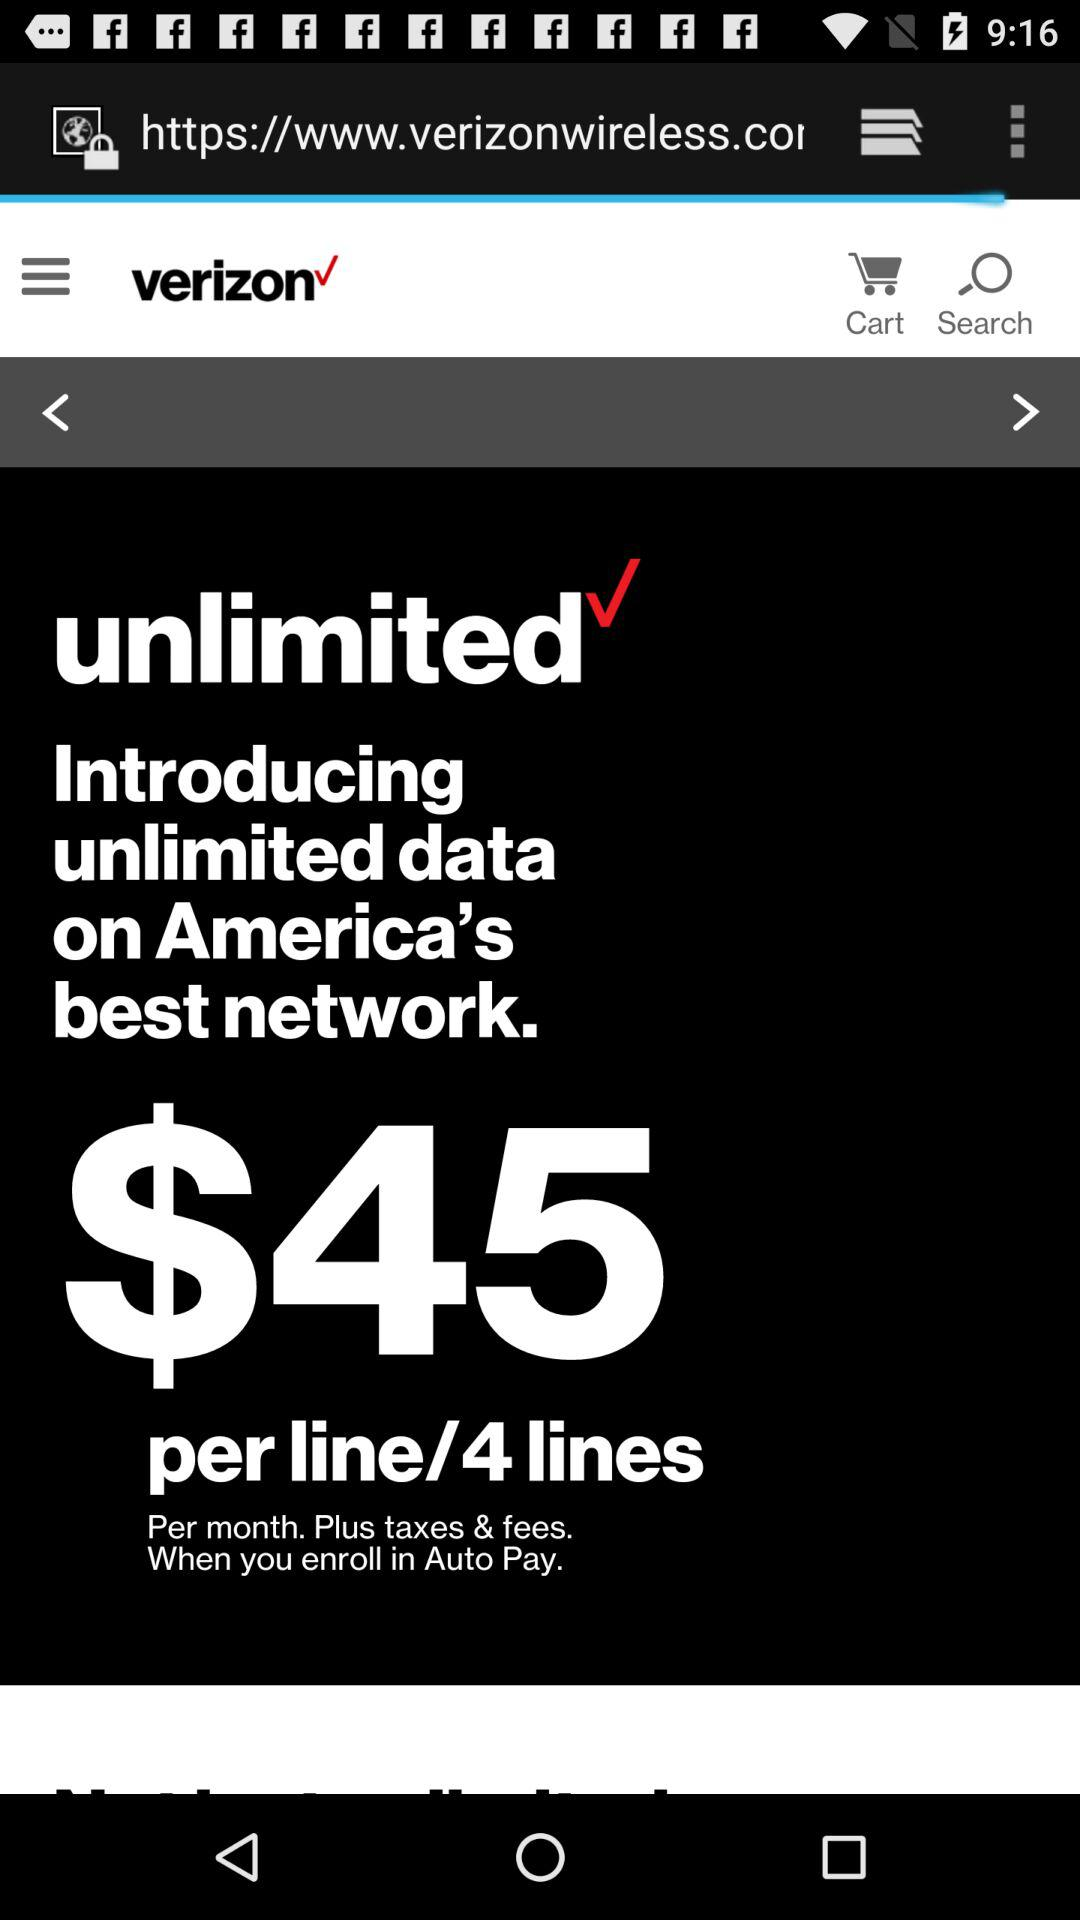How many dollars should we pay for unlimited data on America's best network? The price is $45. 